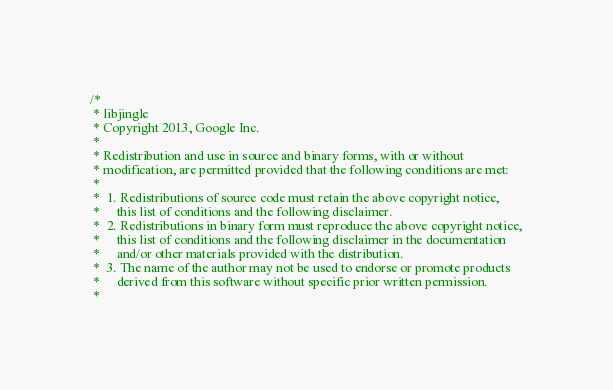Convert code to text. <code><loc_0><loc_0><loc_500><loc_500><_ObjectiveC_>/*
 * libjingle
 * Copyright 2013, Google Inc.
 *
 * Redistribution and use in source and binary forms, with or without
 * modification, are permitted provided that the following conditions are met:
 *
 *  1. Redistributions of source code must retain the above copyright notice,
 *     this list of conditions and the following disclaimer.
 *  2. Redistributions in binary form must reproduce the above copyright notice,
 *     this list of conditions and the following disclaimer in the documentation
 *     and/or other materials provided with the distribution.
 *  3. The name of the author may not be used to endorse or promote products
 *     derived from this software without specific prior written permission.
 *</code> 